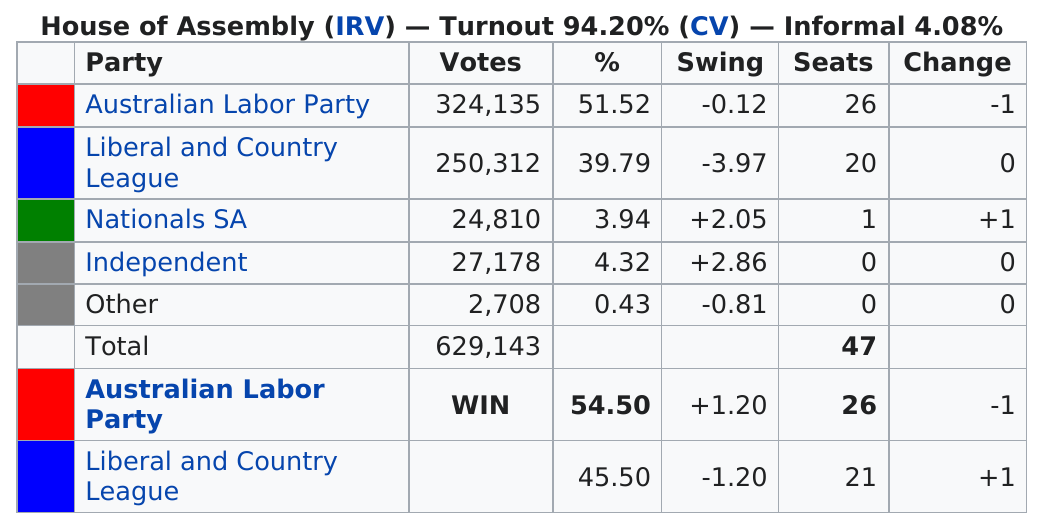Give some essential details in this illustration. Liberal and Country League won a total of 20 seats in the most recent election. The Australian Labor Party received the most votes in the recent election. The party that received the least number of votes was the "Other" party. There were 305,008 votes that were not attributed to the Australian Labor Party The Nationals and the Independent Party received a combined total of 8.26% of the votes in the election. 